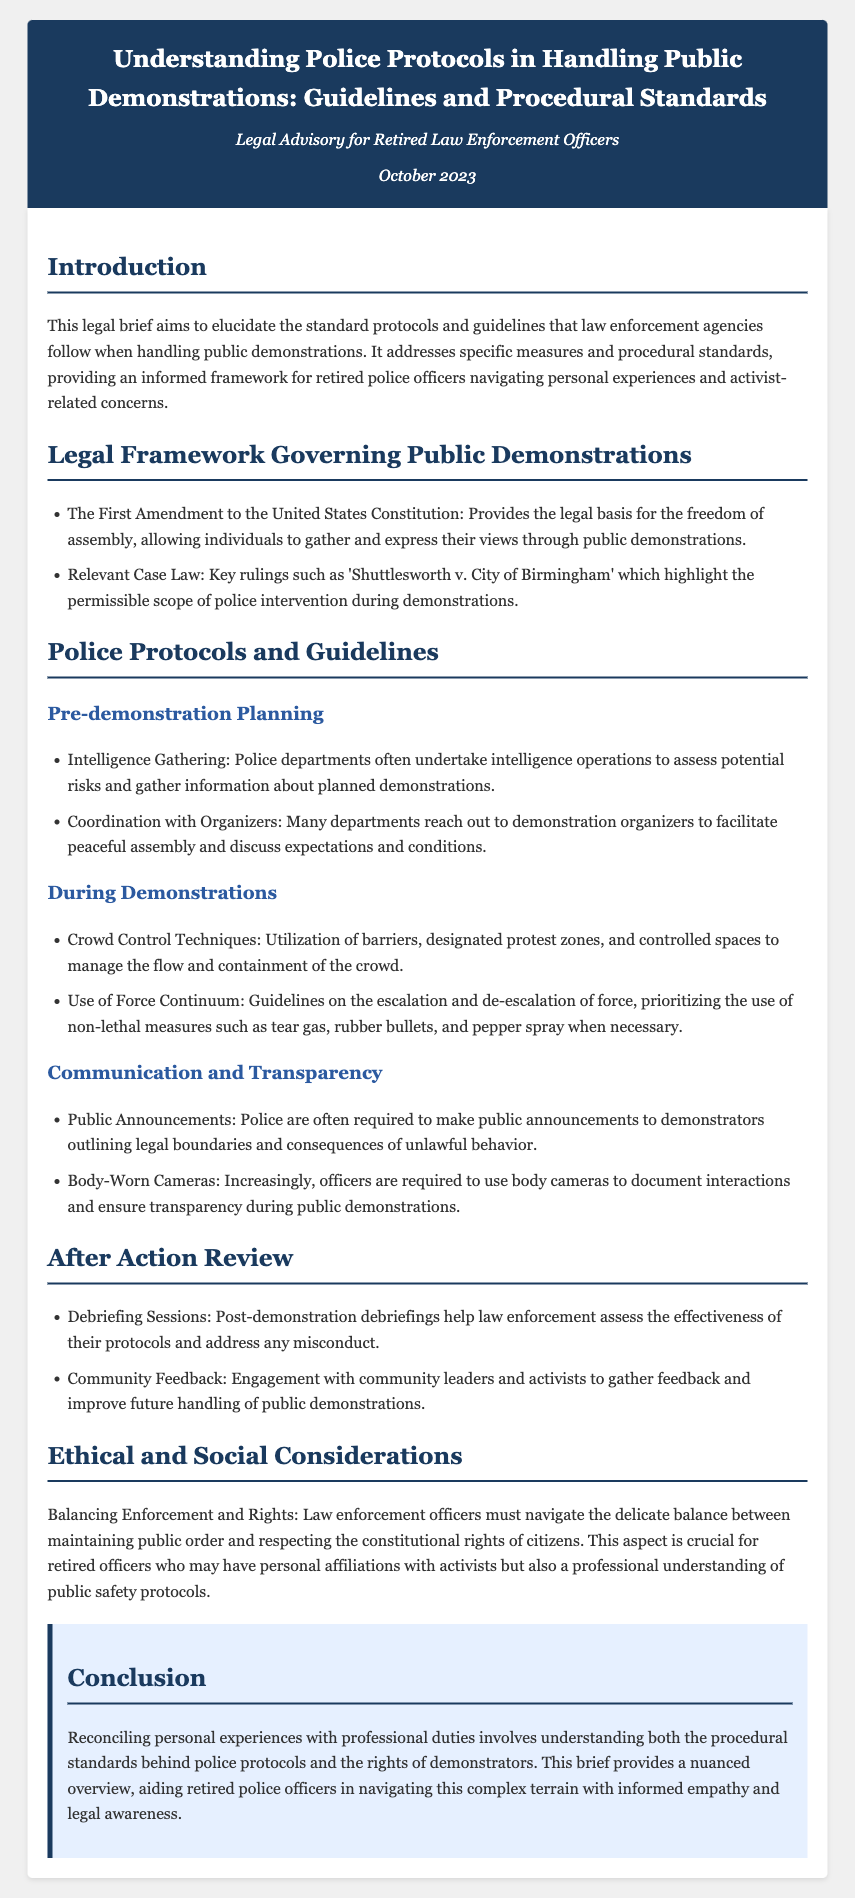What does the First Amendment provide? The First Amendment provides the legal basis for the freedom of assembly, allowing individuals to gather and express their views through public demonstrations.
Answer: freedom of assembly What is a key case mentioned regarding police intervention? The case 'Shuttlesworth v. City of Birmingham' highlights the permissible scope of police intervention during demonstrations.
Answer: Shuttlesworth v. City of Birmingham What is one goal of police during pre-demonstration planning? Police departments undertake intelligence operations to assess potential risks and gather information about planned demonstrations.
Answer: Intelligence Gathering What is used for communication during demonstrations? Police are often required to make public announcements to demonstrators outlining legal boundaries and consequences of unlawful behavior.
Answer: Public Announcements What does the police use to document interactions? Increasingly, officers are required to use body cameras to document interactions and ensure transparency during public demonstrations.
Answer: Body-Worn Cameras What is a method of crowd control mentioned? Utilization of barriers, designated protest zones, and controlled spaces to manage the flow and containment of the crowd is mentioned.
Answer: Barriers What facilitates post-demonstration improvement? Engagement with community leaders and activists to gather feedback and improve future handling of public demonstrations aids in post-demonstration improvement.
Answer: Community Feedback What is a critical ethical consideration for law enforcement? Law enforcement officers must navigate the delicate balance between maintaining public order and respecting the constitutional rights of citizens.
Answer: Balancing Enforcement and Rights Who is the intended audience of this legal brief? The brief aims to elucidate the standard protocols and guidelines for retired police officers navigating personal experiences and activist-related concerns.
Answer: Retired police officers 